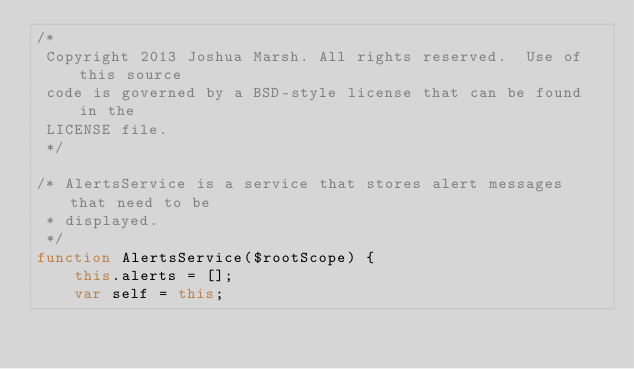<code> <loc_0><loc_0><loc_500><loc_500><_JavaScript_>/*
 Copyright 2013 Joshua Marsh. All rights reserved.  Use of this source
 code is governed by a BSD-style license that can be found in the
 LICENSE file.
 */

/* AlertsService is a service that stores alert messages that need to be
 * displayed.
 */
function AlertsService($rootScope) {
		this.alerts = [];
		var self = this;
</code> 